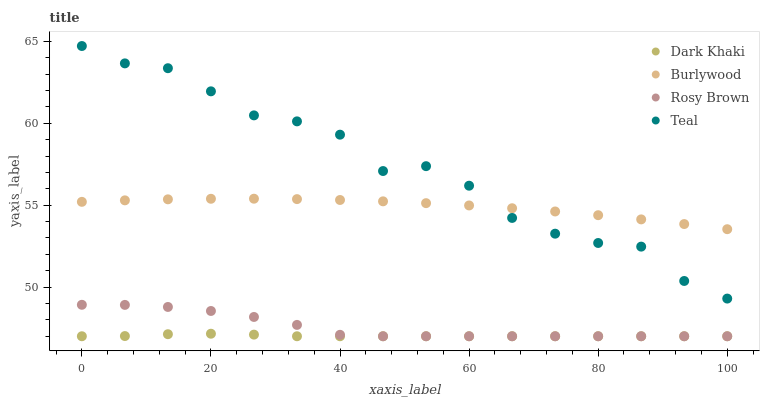Does Dark Khaki have the minimum area under the curve?
Answer yes or no. Yes. Does Teal have the maximum area under the curve?
Answer yes or no. Yes. Does Burlywood have the minimum area under the curve?
Answer yes or no. No. Does Burlywood have the maximum area under the curve?
Answer yes or no. No. Is Burlywood the smoothest?
Answer yes or no. Yes. Is Teal the roughest?
Answer yes or no. Yes. Is Rosy Brown the smoothest?
Answer yes or no. No. Is Rosy Brown the roughest?
Answer yes or no. No. Does Dark Khaki have the lowest value?
Answer yes or no. Yes. Does Burlywood have the lowest value?
Answer yes or no. No. Does Teal have the highest value?
Answer yes or no. Yes. Does Burlywood have the highest value?
Answer yes or no. No. Is Dark Khaki less than Burlywood?
Answer yes or no. Yes. Is Burlywood greater than Rosy Brown?
Answer yes or no. Yes. Does Rosy Brown intersect Dark Khaki?
Answer yes or no. Yes. Is Rosy Brown less than Dark Khaki?
Answer yes or no. No. Is Rosy Brown greater than Dark Khaki?
Answer yes or no. No. Does Dark Khaki intersect Burlywood?
Answer yes or no. No. 